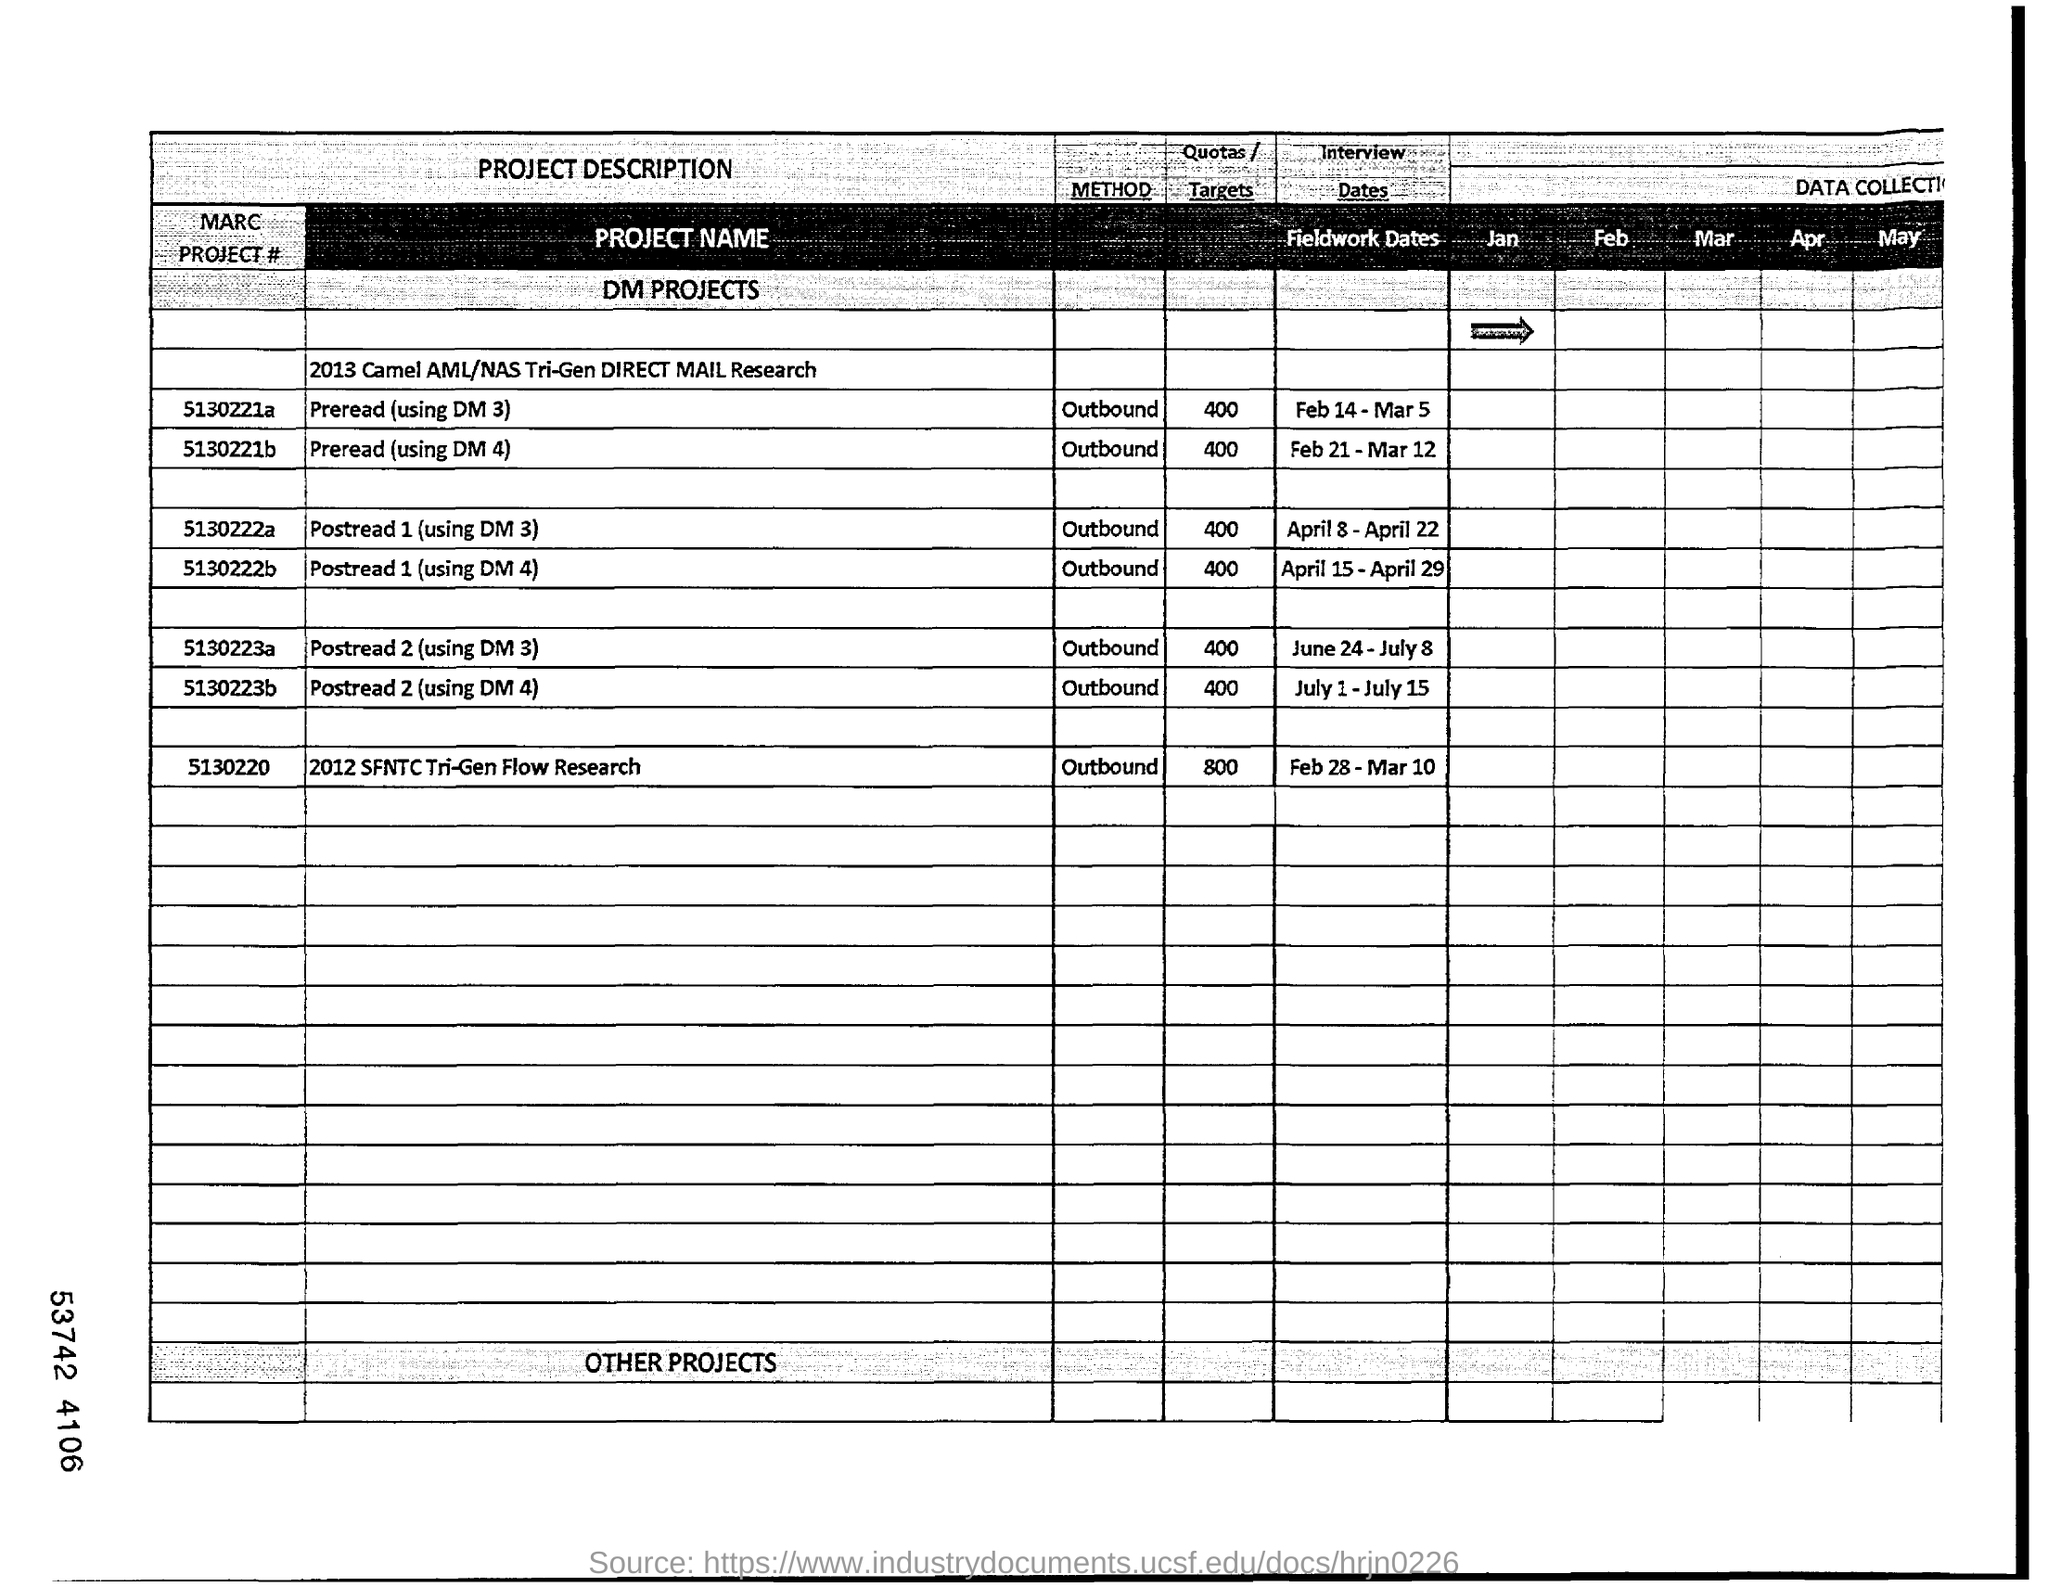Point out several critical features in this image. What is the "Quotas/Targets" of MARC PROJECT # 5130220? It is unknown, but it is estimated to be between 800 and 1000. The date mentioned under "Interview Dates" for MARC PROJECT # 5130222a is April 8 to April 22. The quotas or targets for MARC PROJECT # 5130221a are currently set at 400. In the given text, the phrase "Mention the "PROJECT NAME" of MARC PROJECT # "5130221a" given in the table is a directive or instruction asking the reader to acknowledge or reference the specified project. The text is asking the reader to recognize the project named in the table and to mention it in some way, whether that be by referencing it in an upcoming section or simply acknowledging its existence. The quotas/targets for MARC PROJECT #5130222a are currently set at 400. 